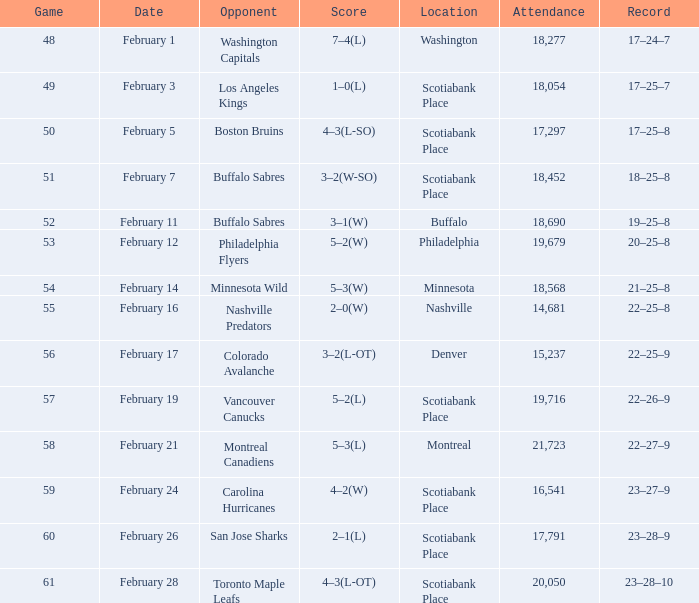For what game was the attendance figure 18,690? 52.0. 